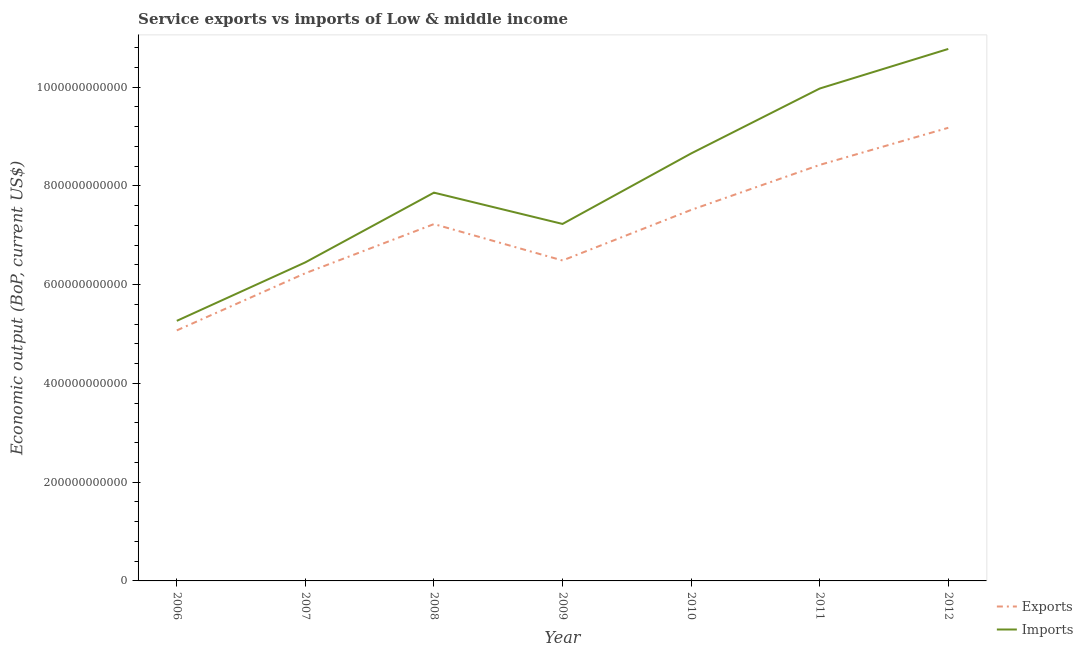How many different coloured lines are there?
Offer a very short reply. 2. Does the line corresponding to amount of service exports intersect with the line corresponding to amount of service imports?
Offer a terse response. No. Is the number of lines equal to the number of legend labels?
Your answer should be very brief. Yes. What is the amount of service imports in 2009?
Give a very brief answer. 7.23e+11. Across all years, what is the maximum amount of service imports?
Your answer should be very brief. 1.08e+12. Across all years, what is the minimum amount of service exports?
Give a very brief answer. 5.07e+11. In which year was the amount of service exports maximum?
Your answer should be compact. 2012. In which year was the amount of service exports minimum?
Make the answer very short. 2006. What is the total amount of service exports in the graph?
Keep it short and to the point. 5.01e+12. What is the difference between the amount of service imports in 2009 and that in 2010?
Make the answer very short. -1.43e+11. What is the difference between the amount of service exports in 2010 and the amount of service imports in 2006?
Your response must be concise. 2.25e+11. What is the average amount of service imports per year?
Offer a terse response. 8.03e+11. In the year 2012, what is the difference between the amount of service exports and amount of service imports?
Your answer should be very brief. -1.60e+11. In how many years, is the amount of service exports greater than 360000000000 US$?
Your answer should be compact. 7. What is the ratio of the amount of service exports in 2007 to that in 2011?
Your answer should be compact. 0.74. Is the difference between the amount of service imports in 2010 and 2011 greater than the difference between the amount of service exports in 2010 and 2011?
Offer a terse response. No. What is the difference between the highest and the second highest amount of service imports?
Offer a very short reply. 8.02e+1. What is the difference between the highest and the lowest amount of service exports?
Your answer should be very brief. 4.10e+11. Does the amount of service exports monotonically increase over the years?
Offer a terse response. No. Is the amount of service imports strictly greater than the amount of service exports over the years?
Your response must be concise. Yes. How many lines are there?
Give a very brief answer. 2. How many years are there in the graph?
Offer a terse response. 7. What is the difference between two consecutive major ticks on the Y-axis?
Offer a very short reply. 2.00e+11. Are the values on the major ticks of Y-axis written in scientific E-notation?
Offer a terse response. No. Does the graph contain grids?
Keep it short and to the point. No. Where does the legend appear in the graph?
Offer a terse response. Bottom right. How many legend labels are there?
Provide a succinct answer. 2. How are the legend labels stacked?
Give a very brief answer. Vertical. What is the title of the graph?
Offer a very short reply. Service exports vs imports of Low & middle income. Does "Current education expenditure" appear as one of the legend labels in the graph?
Give a very brief answer. No. What is the label or title of the Y-axis?
Keep it short and to the point. Economic output (BoP, current US$). What is the Economic output (BoP, current US$) in Exports in 2006?
Offer a very short reply. 5.07e+11. What is the Economic output (BoP, current US$) of Imports in 2006?
Offer a terse response. 5.27e+11. What is the Economic output (BoP, current US$) of Exports in 2007?
Give a very brief answer. 6.23e+11. What is the Economic output (BoP, current US$) in Imports in 2007?
Provide a short and direct response. 6.45e+11. What is the Economic output (BoP, current US$) in Exports in 2008?
Offer a very short reply. 7.23e+11. What is the Economic output (BoP, current US$) in Imports in 2008?
Provide a short and direct response. 7.86e+11. What is the Economic output (BoP, current US$) of Exports in 2009?
Your response must be concise. 6.49e+11. What is the Economic output (BoP, current US$) of Imports in 2009?
Give a very brief answer. 7.23e+11. What is the Economic output (BoP, current US$) in Exports in 2010?
Your answer should be compact. 7.51e+11. What is the Economic output (BoP, current US$) in Imports in 2010?
Provide a succinct answer. 8.66e+11. What is the Economic output (BoP, current US$) of Exports in 2011?
Your response must be concise. 8.42e+11. What is the Economic output (BoP, current US$) in Imports in 2011?
Your answer should be very brief. 9.97e+11. What is the Economic output (BoP, current US$) in Exports in 2012?
Make the answer very short. 9.18e+11. What is the Economic output (BoP, current US$) of Imports in 2012?
Provide a short and direct response. 1.08e+12. Across all years, what is the maximum Economic output (BoP, current US$) of Exports?
Keep it short and to the point. 9.18e+11. Across all years, what is the maximum Economic output (BoP, current US$) of Imports?
Make the answer very short. 1.08e+12. Across all years, what is the minimum Economic output (BoP, current US$) of Exports?
Keep it short and to the point. 5.07e+11. Across all years, what is the minimum Economic output (BoP, current US$) of Imports?
Offer a terse response. 5.27e+11. What is the total Economic output (BoP, current US$) in Exports in the graph?
Make the answer very short. 5.01e+12. What is the total Economic output (BoP, current US$) in Imports in the graph?
Keep it short and to the point. 5.62e+12. What is the difference between the Economic output (BoP, current US$) in Exports in 2006 and that in 2007?
Give a very brief answer. -1.16e+11. What is the difference between the Economic output (BoP, current US$) of Imports in 2006 and that in 2007?
Provide a succinct answer. -1.18e+11. What is the difference between the Economic output (BoP, current US$) of Exports in 2006 and that in 2008?
Make the answer very short. -2.15e+11. What is the difference between the Economic output (BoP, current US$) of Imports in 2006 and that in 2008?
Your answer should be compact. -2.60e+11. What is the difference between the Economic output (BoP, current US$) of Exports in 2006 and that in 2009?
Your answer should be compact. -1.42e+11. What is the difference between the Economic output (BoP, current US$) of Imports in 2006 and that in 2009?
Keep it short and to the point. -1.96e+11. What is the difference between the Economic output (BoP, current US$) in Exports in 2006 and that in 2010?
Your answer should be compact. -2.44e+11. What is the difference between the Economic output (BoP, current US$) in Imports in 2006 and that in 2010?
Offer a terse response. -3.39e+11. What is the difference between the Economic output (BoP, current US$) of Exports in 2006 and that in 2011?
Offer a terse response. -3.35e+11. What is the difference between the Economic output (BoP, current US$) of Imports in 2006 and that in 2011?
Provide a succinct answer. -4.70e+11. What is the difference between the Economic output (BoP, current US$) of Exports in 2006 and that in 2012?
Keep it short and to the point. -4.10e+11. What is the difference between the Economic output (BoP, current US$) of Imports in 2006 and that in 2012?
Your answer should be compact. -5.51e+11. What is the difference between the Economic output (BoP, current US$) in Exports in 2007 and that in 2008?
Provide a succinct answer. -9.95e+1. What is the difference between the Economic output (BoP, current US$) in Imports in 2007 and that in 2008?
Give a very brief answer. -1.41e+11. What is the difference between the Economic output (BoP, current US$) of Exports in 2007 and that in 2009?
Provide a short and direct response. -2.58e+1. What is the difference between the Economic output (BoP, current US$) of Imports in 2007 and that in 2009?
Provide a short and direct response. -7.78e+1. What is the difference between the Economic output (BoP, current US$) of Exports in 2007 and that in 2010?
Make the answer very short. -1.28e+11. What is the difference between the Economic output (BoP, current US$) of Imports in 2007 and that in 2010?
Ensure brevity in your answer.  -2.21e+11. What is the difference between the Economic output (BoP, current US$) of Exports in 2007 and that in 2011?
Your answer should be very brief. -2.19e+11. What is the difference between the Economic output (BoP, current US$) of Imports in 2007 and that in 2011?
Provide a short and direct response. -3.52e+11. What is the difference between the Economic output (BoP, current US$) of Exports in 2007 and that in 2012?
Your answer should be compact. -2.94e+11. What is the difference between the Economic output (BoP, current US$) of Imports in 2007 and that in 2012?
Offer a very short reply. -4.32e+11. What is the difference between the Economic output (BoP, current US$) in Exports in 2008 and that in 2009?
Offer a very short reply. 7.37e+1. What is the difference between the Economic output (BoP, current US$) of Imports in 2008 and that in 2009?
Offer a very short reply. 6.34e+1. What is the difference between the Economic output (BoP, current US$) of Exports in 2008 and that in 2010?
Ensure brevity in your answer.  -2.87e+1. What is the difference between the Economic output (BoP, current US$) of Imports in 2008 and that in 2010?
Give a very brief answer. -7.94e+1. What is the difference between the Economic output (BoP, current US$) in Exports in 2008 and that in 2011?
Provide a short and direct response. -1.20e+11. What is the difference between the Economic output (BoP, current US$) of Imports in 2008 and that in 2011?
Keep it short and to the point. -2.11e+11. What is the difference between the Economic output (BoP, current US$) in Exports in 2008 and that in 2012?
Provide a short and direct response. -1.95e+11. What is the difference between the Economic output (BoP, current US$) of Imports in 2008 and that in 2012?
Offer a terse response. -2.91e+11. What is the difference between the Economic output (BoP, current US$) of Exports in 2009 and that in 2010?
Your answer should be compact. -1.02e+11. What is the difference between the Economic output (BoP, current US$) of Imports in 2009 and that in 2010?
Keep it short and to the point. -1.43e+11. What is the difference between the Economic output (BoP, current US$) of Exports in 2009 and that in 2011?
Ensure brevity in your answer.  -1.94e+11. What is the difference between the Economic output (BoP, current US$) of Imports in 2009 and that in 2011?
Keep it short and to the point. -2.74e+11. What is the difference between the Economic output (BoP, current US$) in Exports in 2009 and that in 2012?
Offer a very short reply. -2.69e+11. What is the difference between the Economic output (BoP, current US$) in Imports in 2009 and that in 2012?
Provide a short and direct response. -3.54e+11. What is the difference between the Economic output (BoP, current US$) of Exports in 2010 and that in 2011?
Your answer should be very brief. -9.12e+1. What is the difference between the Economic output (BoP, current US$) of Imports in 2010 and that in 2011?
Provide a succinct answer. -1.31e+11. What is the difference between the Economic output (BoP, current US$) in Exports in 2010 and that in 2012?
Offer a very short reply. -1.66e+11. What is the difference between the Economic output (BoP, current US$) of Imports in 2010 and that in 2012?
Keep it short and to the point. -2.12e+11. What is the difference between the Economic output (BoP, current US$) of Exports in 2011 and that in 2012?
Offer a very short reply. -7.52e+1. What is the difference between the Economic output (BoP, current US$) of Imports in 2011 and that in 2012?
Your answer should be very brief. -8.02e+1. What is the difference between the Economic output (BoP, current US$) of Exports in 2006 and the Economic output (BoP, current US$) of Imports in 2007?
Provide a short and direct response. -1.38e+11. What is the difference between the Economic output (BoP, current US$) of Exports in 2006 and the Economic output (BoP, current US$) of Imports in 2008?
Ensure brevity in your answer.  -2.79e+11. What is the difference between the Economic output (BoP, current US$) of Exports in 2006 and the Economic output (BoP, current US$) of Imports in 2009?
Your answer should be compact. -2.16e+11. What is the difference between the Economic output (BoP, current US$) of Exports in 2006 and the Economic output (BoP, current US$) of Imports in 2010?
Provide a succinct answer. -3.58e+11. What is the difference between the Economic output (BoP, current US$) in Exports in 2006 and the Economic output (BoP, current US$) in Imports in 2011?
Your answer should be very brief. -4.90e+11. What is the difference between the Economic output (BoP, current US$) of Exports in 2006 and the Economic output (BoP, current US$) of Imports in 2012?
Ensure brevity in your answer.  -5.70e+11. What is the difference between the Economic output (BoP, current US$) of Exports in 2007 and the Economic output (BoP, current US$) of Imports in 2008?
Offer a very short reply. -1.63e+11. What is the difference between the Economic output (BoP, current US$) in Exports in 2007 and the Economic output (BoP, current US$) in Imports in 2009?
Offer a terse response. -9.98e+1. What is the difference between the Economic output (BoP, current US$) in Exports in 2007 and the Economic output (BoP, current US$) in Imports in 2010?
Make the answer very short. -2.42e+11. What is the difference between the Economic output (BoP, current US$) of Exports in 2007 and the Economic output (BoP, current US$) of Imports in 2011?
Give a very brief answer. -3.74e+11. What is the difference between the Economic output (BoP, current US$) of Exports in 2007 and the Economic output (BoP, current US$) of Imports in 2012?
Offer a very short reply. -4.54e+11. What is the difference between the Economic output (BoP, current US$) in Exports in 2008 and the Economic output (BoP, current US$) in Imports in 2009?
Provide a succinct answer. -3.01e+08. What is the difference between the Economic output (BoP, current US$) in Exports in 2008 and the Economic output (BoP, current US$) in Imports in 2010?
Your answer should be very brief. -1.43e+11. What is the difference between the Economic output (BoP, current US$) in Exports in 2008 and the Economic output (BoP, current US$) in Imports in 2011?
Make the answer very short. -2.75e+11. What is the difference between the Economic output (BoP, current US$) of Exports in 2008 and the Economic output (BoP, current US$) of Imports in 2012?
Ensure brevity in your answer.  -3.55e+11. What is the difference between the Economic output (BoP, current US$) of Exports in 2009 and the Economic output (BoP, current US$) of Imports in 2010?
Offer a terse response. -2.17e+11. What is the difference between the Economic output (BoP, current US$) of Exports in 2009 and the Economic output (BoP, current US$) of Imports in 2011?
Your answer should be very brief. -3.48e+11. What is the difference between the Economic output (BoP, current US$) of Exports in 2009 and the Economic output (BoP, current US$) of Imports in 2012?
Give a very brief answer. -4.28e+11. What is the difference between the Economic output (BoP, current US$) of Exports in 2010 and the Economic output (BoP, current US$) of Imports in 2011?
Provide a short and direct response. -2.46e+11. What is the difference between the Economic output (BoP, current US$) of Exports in 2010 and the Economic output (BoP, current US$) of Imports in 2012?
Offer a terse response. -3.26e+11. What is the difference between the Economic output (BoP, current US$) of Exports in 2011 and the Economic output (BoP, current US$) of Imports in 2012?
Provide a succinct answer. -2.35e+11. What is the average Economic output (BoP, current US$) in Exports per year?
Make the answer very short. 7.16e+11. What is the average Economic output (BoP, current US$) of Imports per year?
Keep it short and to the point. 8.03e+11. In the year 2006, what is the difference between the Economic output (BoP, current US$) in Exports and Economic output (BoP, current US$) in Imports?
Make the answer very short. -1.93e+1. In the year 2007, what is the difference between the Economic output (BoP, current US$) of Exports and Economic output (BoP, current US$) of Imports?
Your answer should be very brief. -2.20e+1. In the year 2008, what is the difference between the Economic output (BoP, current US$) in Exports and Economic output (BoP, current US$) in Imports?
Provide a succinct answer. -6.37e+1. In the year 2009, what is the difference between the Economic output (BoP, current US$) in Exports and Economic output (BoP, current US$) in Imports?
Provide a succinct answer. -7.40e+1. In the year 2010, what is the difference between the Economic output (BoP, current US$) in Exports and Economic output (BoP, current US$) in Imports?
Keep it short and to the point. -1.14e+11. In the year 2011, what is the difference between the Economic output (BoP, current US$) of Exports and Economic output (BoP, current US$) of Imports?
Your response must be concise. -1.55e+11. In the year 2012, what is the difference between the Economic output (BoP, current US$) in Exports and Economic output (BoP, current US$) in Imports?
Offer a very short reply. -1.60e+11. What is the ratio of the Economic output (BoP, current US$) of Exports in 2006 to that in 2007?
Offer a very short reply. 0.81. What is the ratio of the Economic output (BoP, current US$) in Imports in 2006 to that in 2007?
Provide a succinct answer. 0.82. What is the ratio of the Economic output (BoP, current US$) of Exports in 2006 to that in 2008?
Give a very brief answer. 0.7. What is the ratio of the Economic output (BoP, current US$) in Imports in 2006 to that in 2008?
Keep it short and to the point. 0.67. What is the ratio of the Economic output (BoP, current US$) of Exports in 2006 to that in 2009?
Provide a short and direct response. 0.78. What is the ratio of the Economic output (BoP, current US$) in Imports in 2006 to that in 2009?
Make the answer very short. 0.73. What is the ratio of the Economic output (BoP, current US$) of Exports in 2006 to that in 2010?
Offer a terse response. 0.68. What is the ratio of the Economic output (BoP, current US$) in Imports in 2006 to that in 2010?
Your answer should be very brief. 0.61. What is the ratio of the Economic output (BoP, current US$) of Exports in 2006 to that in 2011?
Your response must be concise. 0.6. What is the ratio of the Economic output (BoP, current US$) in Imports in 2006 to that in 2011?
Your answer should be compact. 0.53. What is the ratio of the Economic output (BoP, current US$) in Exports in 2006 to that in 2012?
Provide a short and direct response. 0.55. What is the ratio of the Economic output (BoP, current US$) in Imports in 2006 to that in 2012?
Give a very brief answer. 0.49. What is the ratio of the Economic output (BoP, current US$) of Exports in 2007 to that in 2008?
Keep it short and to the point. 0.86. What is the ratio of the Economic output (BoP, current US$) of Imports in 2007 to that in 2008?
Keep it short and to the point. 0.82. What is the ratio of the Economic output (BoP, current US$) of Exports in 2007 to that in 2009?
Your answer should be very brief. 0.96. What is the ratio of the Economic output (BoP, current US$) in Imports in 2007 to that in 2009?
Offer a terse response. 0.89. What is the ratio of the Economic output (BoP, current US$) in Exports in 2007 to that in 2010?
Your response must be concise. 0.83. What is the ratio of the Economic output (BoP, current US$) of Imports in 2007 to that in 2010?
Your answer should be compact. 0.75. What is the ratio of the Economic output (BoP, current US$) of Exports in 2007 to that in 2011?
Give a very brief answer. 0.74. What is the ratio of the Economic output (BoP, current US$) of Imports in 2007 to that in 2011?
Your response must be concise. 0.65. What is the ratio of the Economic output (BoP, current US$) in Exports in 2007 to that in 2012?
Provide a short and direct response. 0.68. What is the ratio of the Economic output (BoP, current US$) in Imports in 2007 to that in 2012?
Offer a very short reply. 0.6. What is the ratio of the Economic output (BoP, current US$) in Exports in 2008 to that in 2009?
Give a very brief answer. 1.11. What is the ratio of the Economic output (BoP, current US$) in Imports in 2008 to that in 2009?
Make the answer very short. 1.09. What is the ratio of the Economic output (BoP, current US$) in Exports in 2008 to that in 2010?
Your response must be concise. 0.96. What is the ratio of the Economic output (BoP, current US$) in Imports in 2008 to that in 2010?
Keep it short and to the point. 0.91. What is the ratio of the Economic output (BoP, current US$) in Exports in 2008 to that in 2011?
Offer a very short reply. 0.86. What is the ratio of the Economic output (BoP, current US$) in Imports in 2008 to that in 2011?
Offer a very short reply. 0.79. What is the ratio of the Economic output (BoP, current US$) in Exports in 2008 to that in 2012?
Offer a very short reply. 0.79. What is the ratio of the Economic output (BoP, current US$) in Imports in 2008 to that in 2012?
Offer a terse response. 0.73. What is the ratio of the Economic output (BoP, current US$) in Exports in 2009 to that in 2010?
Provide a succinct answer. 0.86. What is the ratio of the Economic output (BoP, current US$) in Imports in 2009 to that in 2010?
Keep it short and to the point. 0.84. What is the ratio of the Economic output (BoP, current US$) of Exports in 2009 to that in 2011?
Your answer should be compact. 0.77. What is the ratio of the Economic output (BoP, current US$) of Imports in 2009 to that in 2011?
Offer a very short reply. 0.72. What is the ratio of the Economic output (BoP, current US$) of Exports in 2009 to that in 2012?
Ensure brevity in your answer.  0.71. What is the ratio of the Economic output (BoP, current US$) of Imports in 2009 to that in 2012?
Make the answer very short. 0.67. What is the ratio of the Economic output (BoP, current US$) of Exports in 2010 to that in 2011?
Provide a succinct answer. 0.89. What is the ratio of the Economic output (BoP, current US$) in Imports in 2010 to that in 2011?
Your answer should be compact. 0.87. What is the ratio of the Economic output (BoP, current US$) of Exports in 2010 to that in 2012?
Offer a terse response. 0.82. What is the ratio of the Economic output (BoP, current US$) of Imports in 2010 to that in 2012?
Ensure brevity in your answer.  0.8. What is the ratio of the Economic output (BoP, current US$) of Exports in 2011 to that in 2012?
Provide a succinct answer. 0.92. What is the ratio of the Economic output (BoP, current US$) in Imports in 2011 to that in 2012?
Your response must be concise. 0.93. What is the difference between the highest and the second highest Economic output (BoP, current US$) in Exports?
Offer a terse response. 7.52e+1. What is the difference between the highest and the second highest Economic output (BoP, current US$) in Imports?
Offer a very short reply. 8.02e+1. What is the difference between the highest and the lowest Economic output (BoP, current US$) of Exports?
Your answer should be very brief. 4.10e+11. What is the difference between the highest and the lowest Economic output (BoP, current US$) of Imports?
Offer a very short reply. 5.51e+11. 